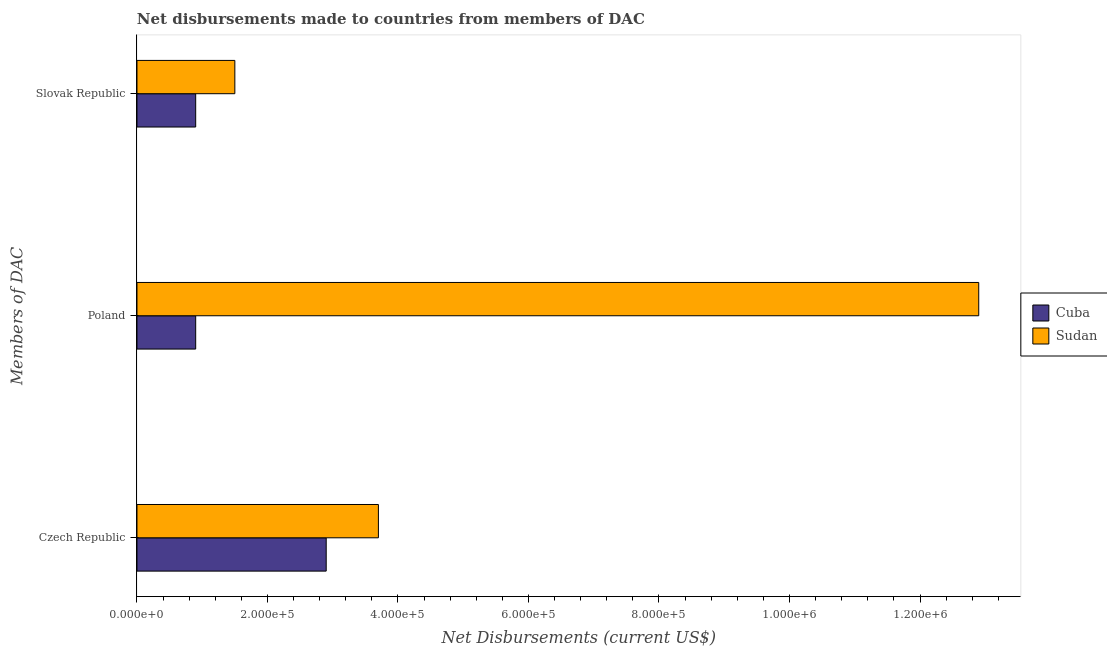How many different coloured bars are there?
Give a very brief answer. 2. How many bars are there on the 3rd tick from the top?
Offer a terse response. 2. How many bars are there on the 1st tick from the bottom?
Your answer should be compact. 2. What is the label of the 3rd group of bars from the top?
Make the answer very short. Czech Republic. What is the net disbursements made by slovak republic in Cuba?
Your answer should be very brief. 9.00e+04. Across all countries, what is the maximum net disbursements made by czech republic?
Give a very brief answer. 3.70e+05. Across all countries, what is the minimum net disbursements made by czech republic?
Make the answer very short. 2.90e+05. In which country was the net disbursements made by slovak republic maximum?
Offer a very short reply. Sudan. In which country was the net disbursements made by poland minimum?
Make the answer very short. Cuba. What is the total net disbursements made by slovak republic in the graph?
Offer a terse response. 2.40e+05. What is the difference between the net disbursements made by slovak republic in Sudan and that in Cuba?
Offer a terse response. 6.00e+04. What is the difference between the net disbursements made by czech republic in Cuba and the net disbursements made by slovak republic in Sudan?
Offer a very short reply. 1.40e+05. What is the average net disbursements made by poland per country?
Provide a short and direct response. 6.90e+05. What is the difference between the net disbursements made by poland and net disbursements made by slovak republic in Sudan?
Your answer should be compact. 1.14e+06. What is the ratio of the net disbursements made by czech republic in Cuba to that in Sudan?
Offer a terse response. 0.78. What is the difference between the highest and the second highest net disbursements made by poland?
Offer a terse response. 1.20e+06. What is the difference between the highest and the lowest net disbursements made by poland?
Give a very brief answer. 1.20e+06. Is the sum of the net disbursements made by poland in Cuba and Sudan greater than the maximum net disbursements made by czech republic across all countries?
Provide a succinct answer. Yes. What does the 2nd bar from the top in Slovak Republic represents?
Offer a very short reply. Cuba. What does the 1st bar from the bottom in Czech Republic represents?
Your answer should be compact. Cuba. Is it the case that in every country, the sum of the net disbursements made by czech republic and net disbursements made by poland is greater than the net disbursements made by slovak republic?
Your answer should be very brief. Yes. How many bars are there?
Offer a terse response. 6. Are all the bars in the graph horizontal?
Your answer should be compact. Yes. How many countries are there in the graph?
Offer a terse response. 2. What is the difference between two consecutive major ticks on the X-axis?
Make the answer very short. 2.00e+05. Does the graph contain grids?
Your answer should be very brief. No. Where does the legend appear in the graph?
Offer a terse response. Center right. What is the title of the graph?
Make the answer very short. Net disbursements made to countries from members of DAC. Does "Chile" appear as one of the legend labels in the graph?
Make the answer very short. No. What is the label or title of the X-axis?
Give a very brief answer. Net Disbursements (current US$). What is the label or title of the Y-axis?
Provide a short and direct response. Members of DAC. What is the Net Disbursements (current US$) of Cuba in Czech Republic?
Provide a short and direct response. 2.90e+05. What is the Net Disbursements (current US$) of Sudan in Czech Republic?
Offer a very short reply. 3.70e+05. What is the Net Disbursements (current US$) in Sudan in Poland?
Keep it short and to the point. 1.29e+06. What is the Net Disbursements (current US$) in Sudan in Slovak Republic?
Your response must be concise. 1.50e+05. Across all Members of DAC, what is the maximum Net Disbursements (current US$) of Cuba?
Give a very brief answer. 2.90e+05. Across all Members of DAC, what is the maximum Net Disbursements (current US$) of Sudan?
Give a very brief answer. 1.29e+06. Across all Members of DAC, what is the minimum Net Disbursements (current US$) in Cuba?
Provide a succinct answer. 9.00e+04. Across all Members of DAC, what is the minimum Net Disbursements (current US$) of Sudan?
Your response must be concise. 1.50e+05. What is the total Net Disbursements (current US$) in Cuba in the graph?
Make the answer very short. 4.70e+05. What is the total Net Disbursements (current US$) in Sudan in the graph?
Make the answer very short. 1.81e+06. What is the difference between the Net Disbursements (current US$) of Sudan in Czech Republic and that in Poland?
Make the answer very short. -9.20e+05. What is the difference between the Net Disbursements (current US$) in Sudan in Poland and that in Slovak Republic?
Offer a very short reply. 1.14e+06. What is the average Net Disbursements (current US$) of Cuba per Members of DAC?
Give a very brief answer. 1.57e+05. What is the average Net Disbursements (current US$) in Sudan per Members of DAC?
Offer a very short reply. 6.03e+05. What is the difference between the Net Disbursements (current US$) in Cuba and Net Disbursements (current US$) in Sudan in Czech Republic?
Provide a succinct answer. -8.00e+04. What is the difference between the Net Disbursements (current US$) in Cuba and Net Disbursements (current US$) in Sudan in Poland?
Provide a succinct answer. -1.20e+06. What is the ratio of the Net Disbursements (current US$) in Cuba in Czech Republic to that in Poland?
Make the answer very short. 3.22. What is the ratio of the Net Disbursements (current US$) in Sudan in Czech Republic to that in Poland?
Give a very brief answer. 0.29. What is the ratio of the Net Disbursements (current US$) of Cuba in Czech Republic to that in Slovak Republic?
Your answer should be compact. 3.22. What is the ratio of the Net Disbursements (current US$) in Sudan in Czech Republic to that in Slovak Republic?
Your answer should be very brief. 2.47. What is the ratio of the Net Disbursements (current US$) of Sudan in Poland to that in Slovak Republic?
Provide a short and direct response. 8.6. What is the difference between the highest and the second highest Net Disbursements (current US$) in Cuba?
Your answer should be compact. 2.00e+05. What is the difference between the highest and the second highest Net Disbursements (current US$) of Sudan?
Offer a terse response. 9.20e+05. What is the difference between the highest and the lowest Net Disbursements (current US$) of Cuba?
Your response must be concise. 2.00e+05. What is the difference between the highest and the lowest Net Disbursements (current US$) of Sudan?
Provide a succinct answer. 1.14e+06. 